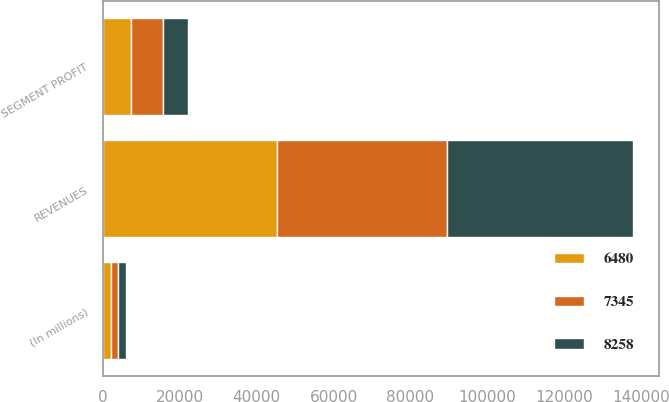Convert chart to OTSL. <chart><loc_0><loc_0><loc_500><loc_500><stacked_bar_chart><ecel><fcel>(In millions)<fcel>REVENUES<fcel>SEGMENT PROFIT<nl><fcel>7345<fcel>2013<fcel>44067<fcel>8258<nl><fcel>6480<fcel>2012<fcel>45364<fcel>7345<nl><fcel>8258<fcel>2011<fcel>48324<fcel>6480<nl></chart> 